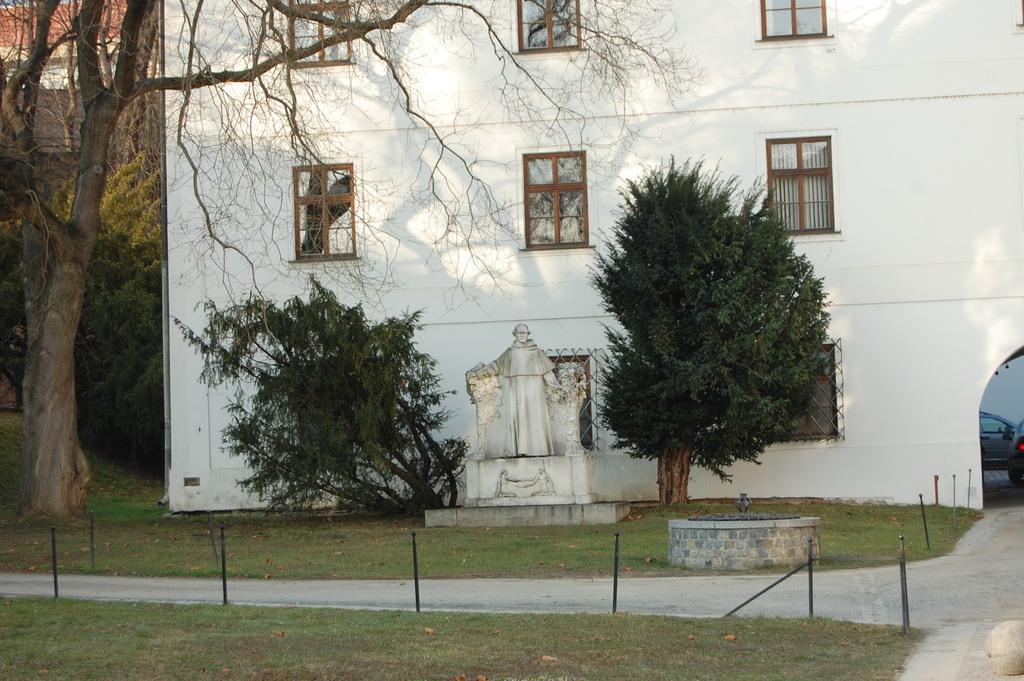How would you summarize this image in a sentence or two? In the center of the image we can see a statue and there are trees. In the background there is a building and we can see windows. On the right we can see cars. At the bottom there is grass. 